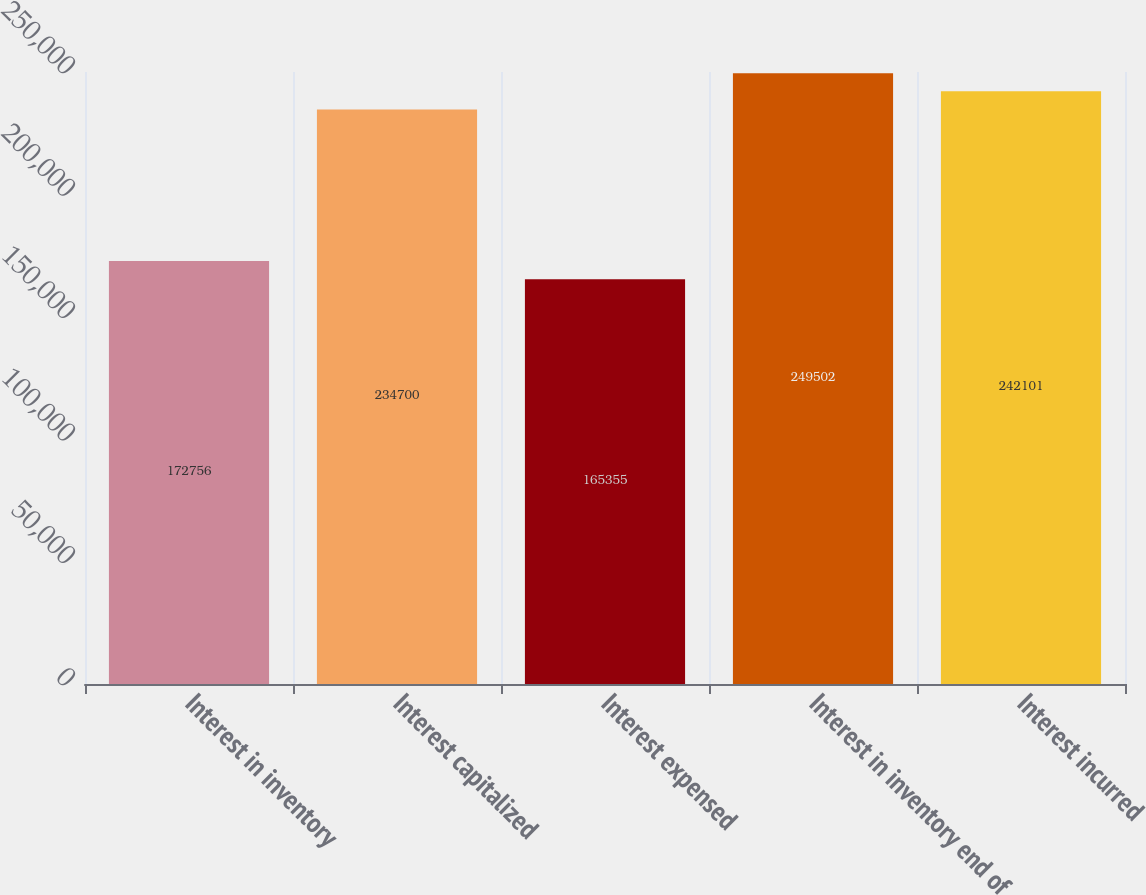Convert chart to OTSL. <chart><loc_0><loc_0><loc_500><loc_500><bar_chart><fcel>Interest in inventory<fcel>Interest capitalized<fcel>Interest expensed<fcel>Interest in inventory end of<fcel>Interest incurred<nl><fcel>172756<fcel>234700<fcel>165355<fcel>249502<fcel>242101<nl></chart> 